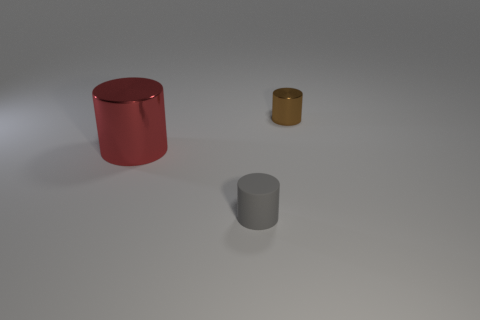Add 1 gray rubber things. How many objects exist? 4 Subtract all tiny rubber objects. Subtract all gray things. How many objects are left? 1 Add 1 cylinders. How many cylinders are left? 4 Add 1 large red shiny cylinders. How many large red shiny cylinders exist? 2 Subtract 1 red cylinders. How many objects are left? 2 